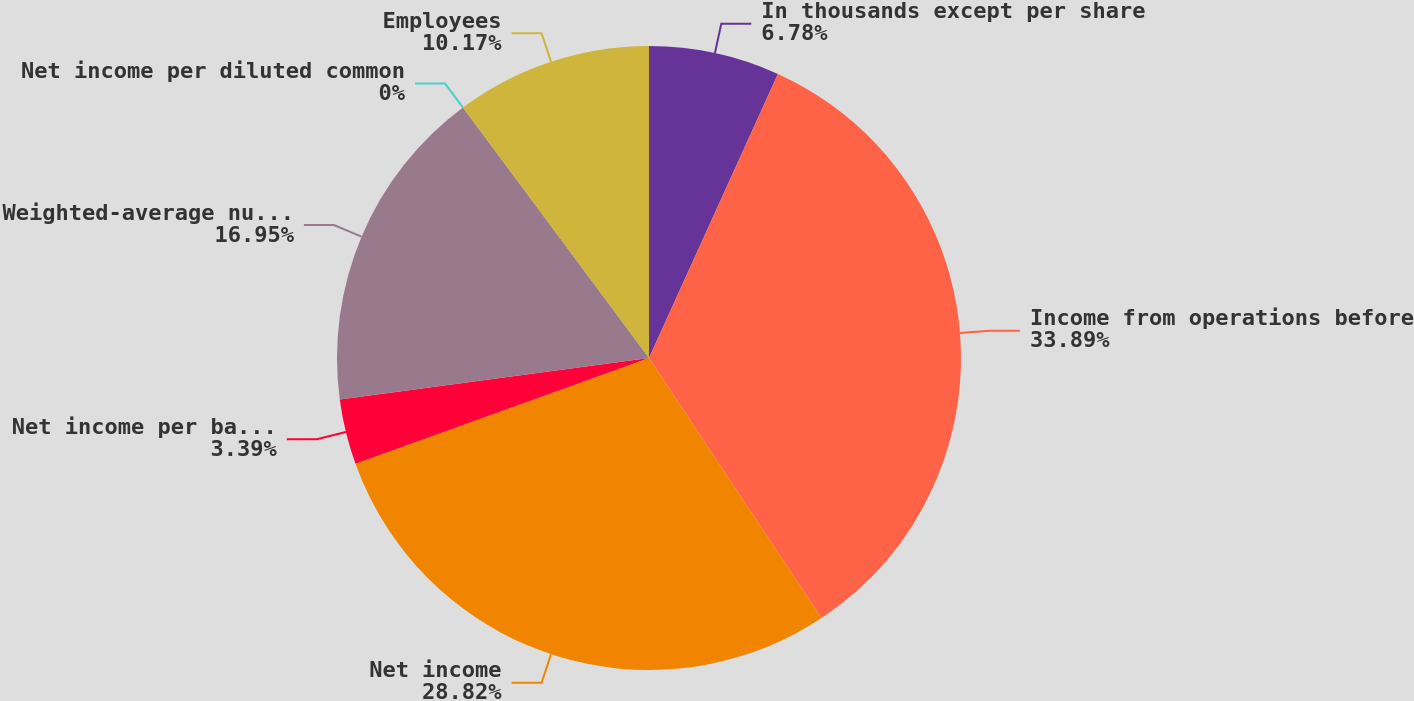Convert chart to OTSL. <chart><loc_0><loc_0><loc_500><loc_500><pie_chart><fcel>In thousands except per share<fcel>Income from operations before<fcel>Net income<fcel>Net income per basic common<fcel>Weighted-average number of<fcel>Net income per diluted common<fcel>Employees<nl><fcel>6.78%<fcel>33.9%<fcel>28.82%<fcel>3.39%<fcel>16.95%<fcel>0.0%<fcel>10.17%<nl></chart> 